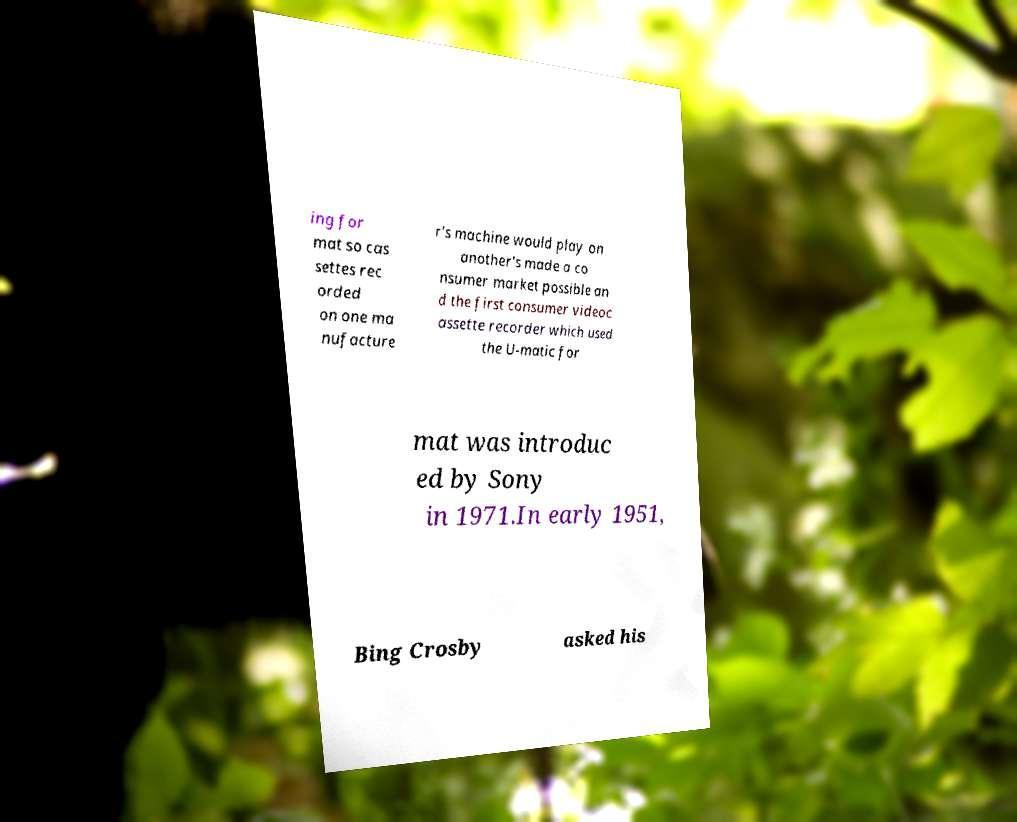Please read and relay the text visible in this image. What does it say? ing for mat so cas settes rec orded on one ma nufacture r's machine would play on another's made a co nsumer market possible an d the first consumer videoc assette recorder which used the U-matic for mat was introduc ed by Sony in 1971.In early 1951, Bing Crosby asked his 